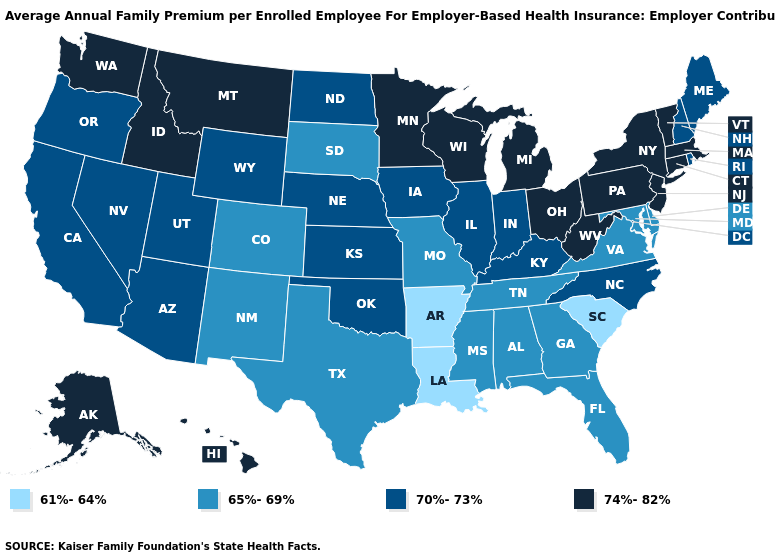Name the states that have a value in the range 65%-69%?
Concise answer only. Alabama, Colorado, Delaware, Florida, Georgia, Maryland, Mississippi, Missouri, New Mexico, South Dakota, Tennessee, Texas, Virginia. What is the value of Rhode Island?
Keep it brief. 70%-73%. Does Texas have the lowest value in the South?
Short answer required. No. Name the states that have a value in the range 61%-64%?
Short answer required. Arkansas, Louisiana, South Carolina. What is the value of Wisconsin?
Quick response, please. 74%-82%. Does Kentucky have the same value as Connecticut?
Be succinct. No. How many symbols are there in the legend?
Concise answer only. 4. What is the value of Kentucky?
Answer briefly. 70%-73%. Which states have the lowest value in the USA?
Keep it brief. Arkansas, Louisiana, South Carolina. What is the highest value in the South ?
Quick response, please. 74%-82%. Name the states that have a value in the range 74%-82%?
Quick response, please. Alaska, Connecticut, Hawaii, Idaho, Massachusetts, Michigan, Minnesota, Montana, New Jersey, New York, Ohio, Pennsylvania, Vermont, Washington, West Virginia, Wisconsin. Name the states that have a value in the range 61%-64%?
Give a very brief answer. Arkansas, Louisiana, South Carolina. What is the value of Idaho?
Quick response, please. 74%-82%. Among the states that border Florida , which have the highest value?
Short answer required. Alabama, Georgia. Does Connecticut have the same value as New Jersey?
Concise answer only. Yes. 